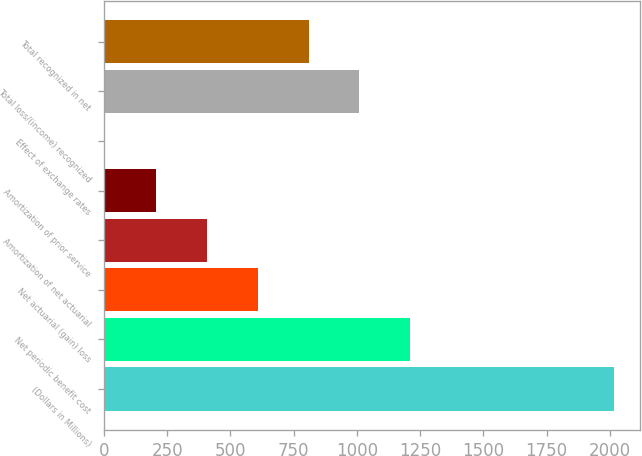Convert chart. <chart><loc_0><loc_0><loc_500><loc_500><bar_chart><fcel>(Dollars in Millions)<fcel>Net periodic benefit cost<fcel>Net actuarial (gain) loss<fcel>Amortization of net actuarial<fcel>Amortization of prior service<fcel>Effect of exchange rates<fcel>Total loss/(income) recognized<fcel>Total recognized in net<nl><fcel>2017<fcel>1211.4<fcel>607.2<fcel>405.8<fcel>204.4<fcel>3<fcel>1010<fcel>808.6<nl></chart> 